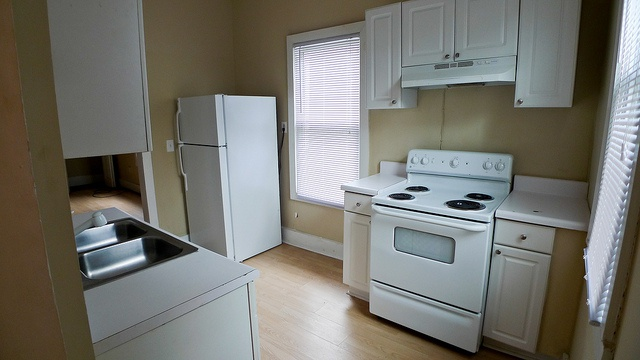Describe the objects in this image and their specific colors. I can see oven in black, darkgray, and gray tones, refrigerator in black, gray, lightgray, and darkgray tones, and sink in black, gray, darkgray, and lightgray tones in this image. 